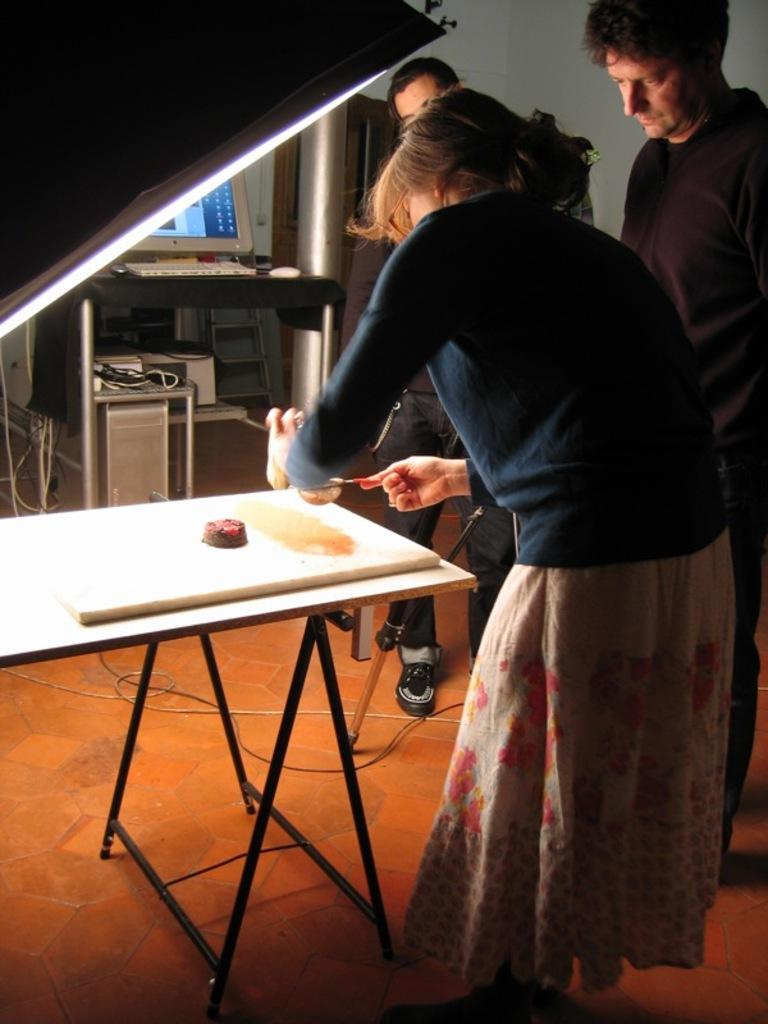How many people are present in the image? There are three people in the image. What are the people doing in the image? The people are standing around a table. Can you describe the activity of the lady among them? A lady among them is doing something on the table. What type of toothpaste is being used by the lady on the table? There is no toothpaste present in the image. What error can be seen on the gate in the image? There is no gate present in the image. 